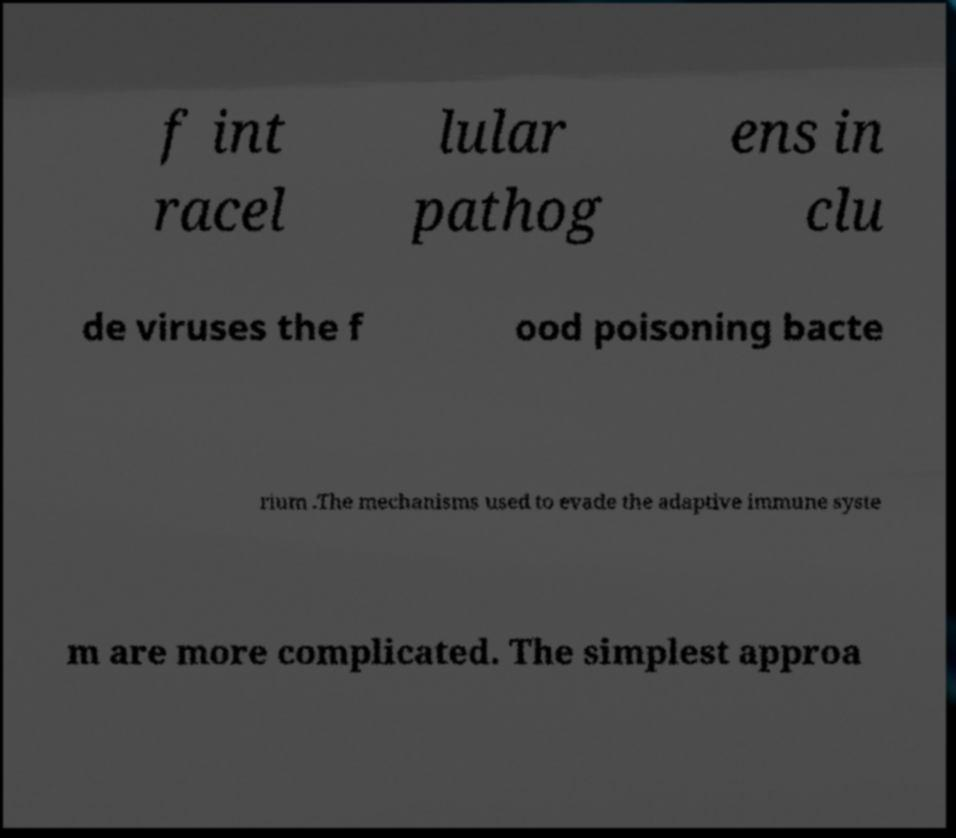Could you assist in decoding the text presented in this image and type it out clearly? f int racel lular pathog ens in clu de viruses the f ood poisoning bacte rium .The mechanisms used to evade the adaptive immune syste m are more complicated. The simplest approa 